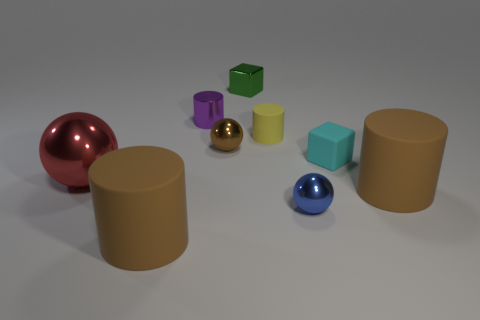Add 1 tiny blue things. How many objects exist? 10 Subtract all blocks. How many objects are left? 7 Add 4 small green metallic objects. How many small green metallic objects exist? 5 Subtract 1 brown cylinders. How many objects are left? 8 Subtract all tiny spheres. Subtract all cyan cubes. How many objects are left? 6 Add 7 big rubber cylinders. How many big rubber cylinders are left? 9 